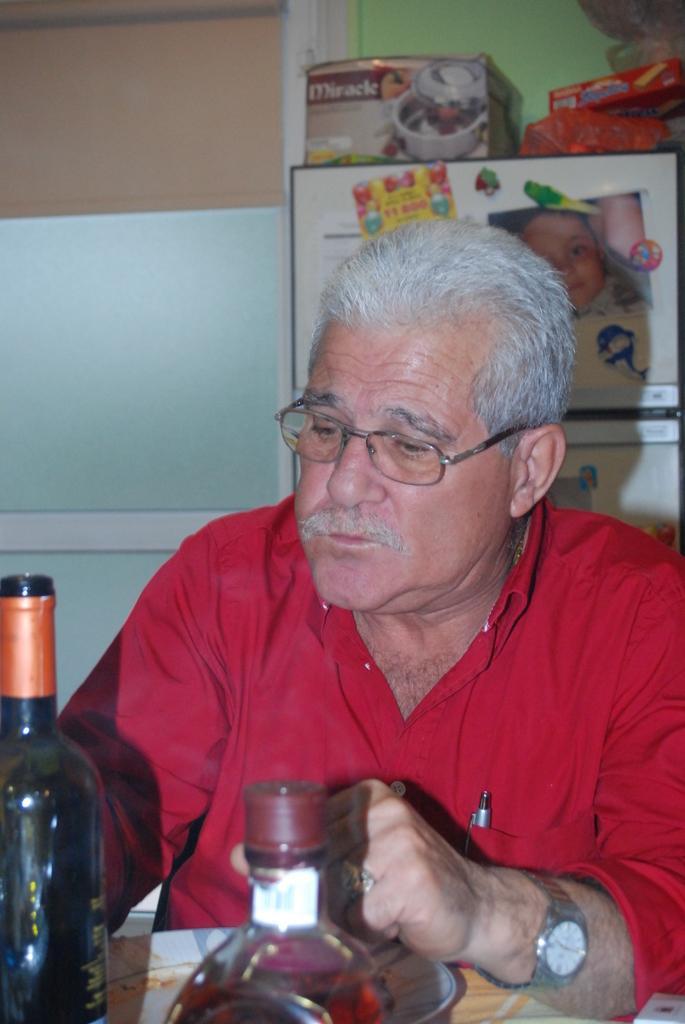How would you summarize this image in a sentence or two? In the picture we can see a man wearing a red shirt and sitting on a chair near the table, on the table we can see two bottles, which is green in color, and which is filled with wine, in the background we can see a wall, glass, and to it there are some pictures hanged on it and some boxes kept in the shelf to the wall. 